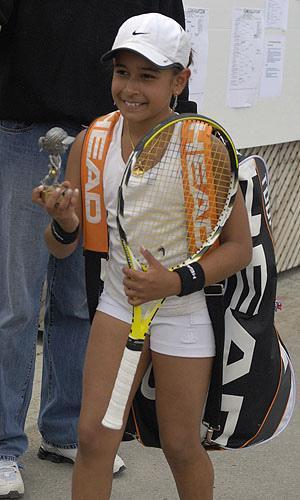How many tennis rackets are visible?
Give a very brief answer. 1. How many people can you see?
Give a very brief answer. 2. 